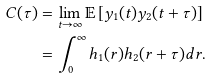<formula> <loc_0><loc_0><loc_500><loc_500>C ( \tau ) & = \lim _ { t \rightarrow \infty } \mathbb { E } \left [ y _ { 1 } ( t ) y _ { 2 } ( t + \tau ) \right ] \\ & = \int _ { 0 } ^ { \infty } h _ { 1 } ( r ) h _ { 2 } ( r + \tau ) d r .</formula> 